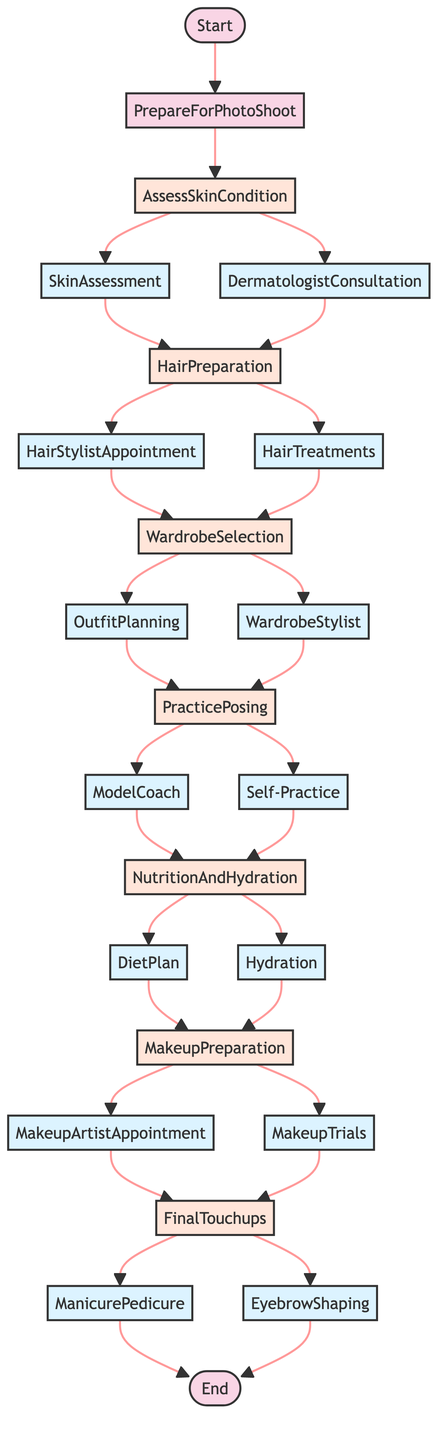What is the first step in preparing for a photo shoot? The flowchart indicates that the first step is "AssessSkinCondition." This is the initial action taken after starting the photo shoot preparation.
Answer: AssessSkinCondition How many main steps are there in the process? Counting the steps in the flowchart reveals a total of 6 main steps: AssessSkinCondition, HairPreparation, WardrobeSelection, PracticePosing, NutritionAndHydration, MakeupPreparation, and FinalTouchups.
Answer: 6 Which step follows "WardrobeSelection"? After "WardrobeSelection," the next steps in the flowchart are "PracticePosing," indicating that this is the sequential action taken immediately after wardrobe selection.
Answer: PracticePosing What actions are associated with "NutritionAndHydration"? The actions associated with "NutritionAndHydration" are "DietPlan" and "Hydration." These two actions provide the necessary nutritional and hydration inputs for the preparation process.
Answer: DietPlan and Hydration What is the final step in the photo shoot preparation process? The last step in the flowchart is "End," which signifies the completion of the preparation process after executing all the previous steps, specifically after "FinalTouchups."
Answer: End Which actions lead to "MakeupPreparation"? The actions leading to "MakeupPreparation" are "DietPlan" and "Hydration," both of which are inputs from the "NutritionAndHydration" step that directly influence the make-up preparation.
Answer: DietPlan and Hydration If I work with a model coach, which step will I follow next? After working with a "ModelCoach," the next step in the flowchart is "NutritionAndHydration," indicating that modeling practice leads into the health and wellness phase of preparation.
Answer: NutritionAndHydration How many total actions lead to the step "FinalTouchups"? There are a total of 4 actions leading to "FinalTouchups": "MakeupArtistAppointment" and "MakeupTrials" flow into it from "MakeupPreparation," while "ManicurePedicure" and "EyebrowShaping" are the actions that finalize the process.
Answer: 4 